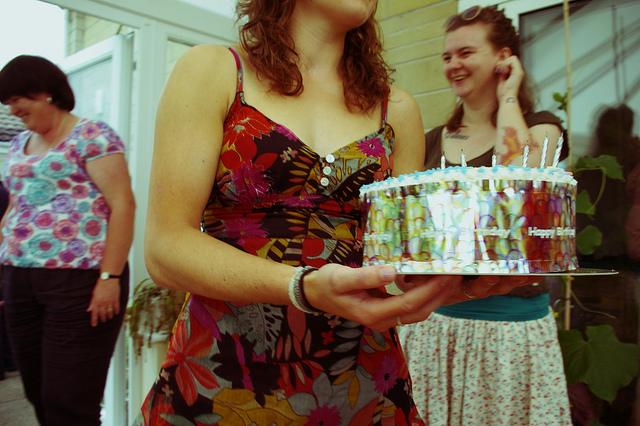What color is the old lady's shirt?
Be succinct. Blue. What food is on the plate?
Give a very brief answer. Cake. How old is the child turning?
Quick response, please. 6. Is the red head a man or a woman?
Keep it brief. Woman. Is the lady wearing a dress?
Concise answer only. Yes. Are all of these females wearing their hair up?
Concise answer only. No. How many people are in the shot?
Keep it brief. 3. Does someone have a birthday?
Keep it brief. Yes. 